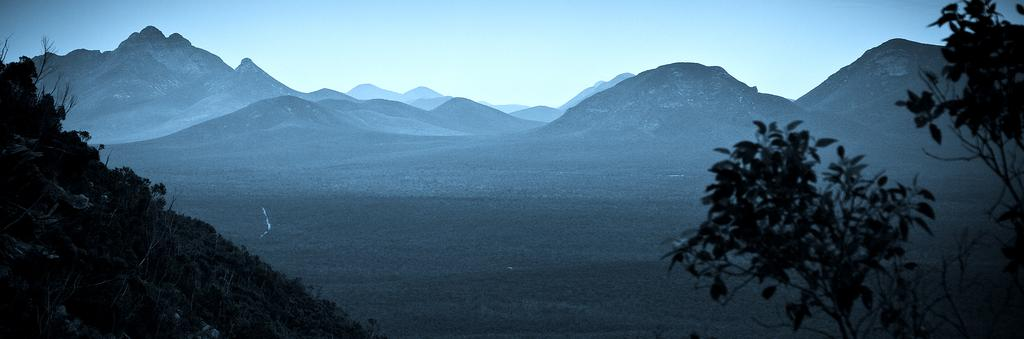What type of vegetation can be seen on the left side of the image? There are plants on the ground on the left side of the image. What is the condition of the tree on the right side of the image? There is a truncated tree on the right side of the image. What natural features can be seen in the background of the image? Mountains and the sky are visible in the background of the image. How many ducks are swimming in the water near the plants on the left side of the image? There are no ducks present in the image; it only features plants on the ground. Can you see a deer grazing in the foreground of the image? There is no deer present in the image; it only features plants, a truncated tree, mountains, and the sky. 